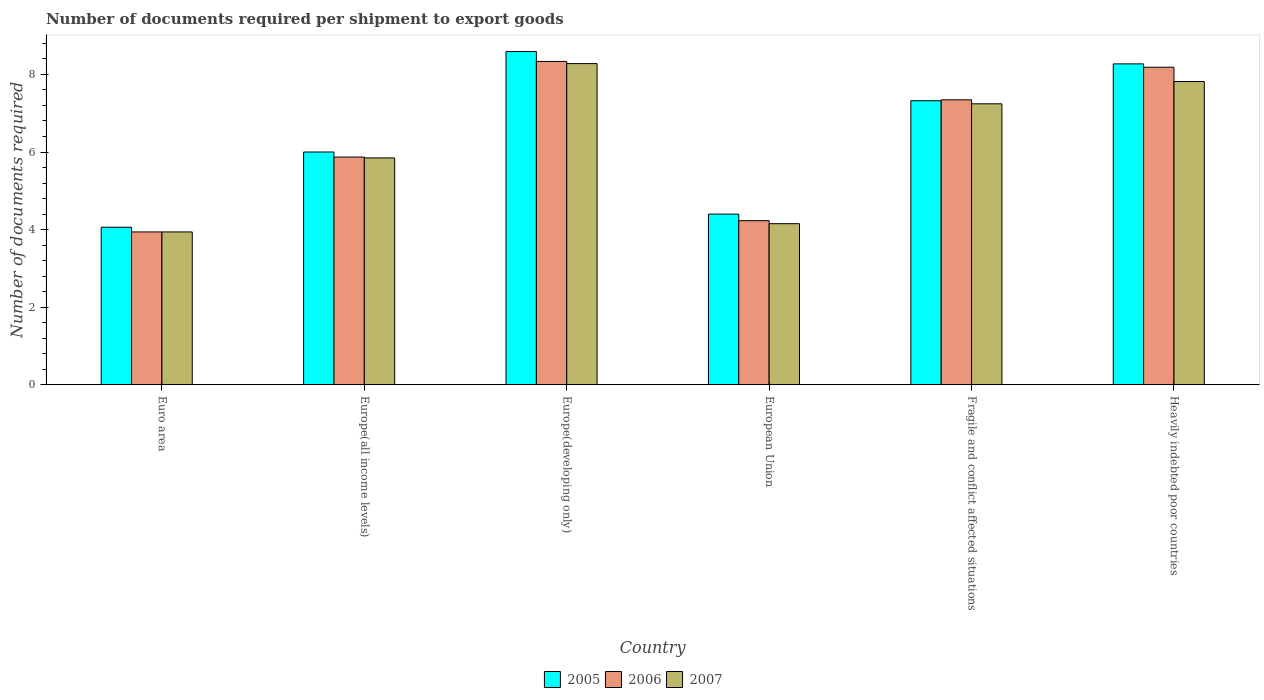How many bars are there on the 6th tick from the left?
Make the answer very short. 3. What is the number of documents required per shipment to export goods in 2005 in Europe(developing only)?
Your answer should be compact. 8.59. Across all countries, what is the maximum number of documents required per shipment to export goods in 2007?
Offer a very short reply. 8.28. Across all countries, what is the minimum number of documents required per shipment to export goods in 2007?
Provide a short and direct response. 3.94. In which country was the number of documents required per shipment to export goods in 2006 maximum?
Provide a short and direct response. Europe(developing only). In which country was the number of documents required per shipment to export goods in 2006 minimum?
Offer a very short reply. Euro area. What is the total number of documents required per shipment to export goods in 2007 in the graph?
Provide a succinct answer. 37.28. What is the difference between the number of documents required per shipment to export goods in 2006 in Fragile and conflict affected situations and that in Heavily indebted poor countries?
Ensure brevity in your answer.  -0.84. What is the difference between the number of documents required per shipment to export goods in 2006 in Europe(all income levels) and the number of documents required per shipment to export goods in 2007 in Heavily indebted poor countries?
Your response must be concise. -1.95. What is the average number of documents required per shipment to export goods in 2005 per country?
Your response must be concise. 6.44. What is the difference between the number of documents required per shipment to export goods of/in 2007 and number of documents required per shipment to export goods of/in 2005 in Fragile and conflict affected situations?
Offer a terse response. -0.08. What is the ratio of the number of documents required per shipment to export goods in 2005 in Europe(all income levels) to that in Fragile and conflict affected situations?
Offer a very short reply. 0.82. Is the number of documents required per shipment to export goods in 2007 in Europe(all income levels) less than that in European Union?
Your answer should be very brief. No. What is the difference between the highest and the second highest number of documents required per shipment to export goods in 2005?
Offer a very short reply. 0.32. What is the difference between the highest and the lowest number of documents required per shipment to export goods in 2006?
Keep it short and to the point. 4.39. In how many countries, is the number of documents required per shipment to export goods in 2007 greater than the average number of documents required per shipment to export goods in 2007 taken over all countries?
Provide a succinct answer. 3. What does the 3rd bar from the left in European Union represents?
Your answer should be very brief. 2007. Is it the case that in every country, the sum of the number of documents required per shipment to export goods in 2005 and number of documents required per shipment to export goods in 2007 is greater than the number of documents required per shipment to export goods in 2006?
Provide a short and direct response. Yes. How many countries are there in the graph?
Offer a terse response. 6. What is the difference between two consecutive major ticks on the Y-axis?
Provide a succinct answer. 2. Where does the legend appear in the graph?
Offer a terse response. Bottom center. What is the title of the graph?
Offer a very short reply. Number of documents required per shipment to export goods. Does "1987" appear as one of the legend labels in the graph?
Give a very brief answer. No. What is the label or title of the X-axis?
Make the answer very short. Country. What is the label or title of the Y-axis?
Provide a succinct answer. Number of documents required. What is the Number of documents required in 2005 in Euro area?
Provide a short and direct response. 4.06. What is the Number of documents required in 2006 in Euro area?
Your answer should be very brief. 3.94. What is the Number of documents required in 2007 in Euro area?
Provide a short and direct response. 3.94. What is the Number of documents required in 2005 in Europe(all income levels)?
Your answer should be compact. 6. What is the Number of documents required in 2006 in Europe(all income levels)?
Offer a terse response. 5.87. What is the Number of documents required in 2007 in Europe(all income levels)?
Provide a succinct answer. 5.85. What is the Number of documents required in 2005 in Europe(developing only)?
Make the answer very short. 8.59. What is the Number of documents required of 2006 in Europe(developing only)?
Make the answer very short. 8.33. What is the Number of documents required of 2007 in Europe(developing only)?
Provide a succinct answer. 8.28. What is the Number of documents required of 2005 in European Union?
Keep it short and to the point. 4.4. What is the Number of documents required in 2006 in European Union?
Your answer should be very brief. 4.23. What is the Number of documents required of 2007 in European Union?
Provide a short and direct response. 4.15. What is the Number of documents required of 2005 in Fragile and conflict affected situations?
Your answer should be compact. 7.32. What is the Number of documents required of 2006 in Fragile and conflict affected situations?
Your answer should be compact. 7.34. What is the Number of documents required of 2007 in Fragile and conflict affected situations?
Your answer should be very brief. 7.24. What is the Number of documents required in 2005 in Heavily indebted poor countries?
Your response must be concise. 8.27. What is the Number of documents required of 2006 in Heavily indebted poor countries?
Keep it short and to the point. 8.18. What is the Number of documents required in 2007 in Heavily indebted poor countries?
Offer a terse response. 7.82. Across all countries, what is the maximum Number of documents required in 2005?
Make the answer very short. 8.59. Across all countries, what is the maximum Number of documents required in 2006?
Your answer should be compact. 8.33. Across all countries, what is the maximum Number of documents required of 2007?
Give a very brief answer. 8.28. Across all countries, what is the minimum Number of documents required in 2005?
Offer a very short reply. 4.06. Across all countries, what is the minimum Number of documents required of 2006?
Keep it short and to the point. 3.94. Across all countries, what is the minimum Number of documents required of 2007?
Offer a very short reply. 3.94. What is the total Number of documents required of 2005 in the graph?
Make the answer very short. 38.64. What is the total Number of documents required in 2006 in the graph?
Keep it short and to the point. 37.9. What is the total Number of documents required of 2007 in the graph?
Provide a short and direct response. 37.28. What is the difference between the Number of documents required of 2005 in Euro area and that in Europe(all income levels)?
Make the answer very short. -1.94. What is the difference between the Number of documents required in 2006 in Euro area and that in Europe(all income levels)?
Make the answer very short. -1.93. What is the difference between the Number of documents required of 2007 in Euro area and that in Europe(all income levels)?
Give a very brief answer. -1.91. What is the difference between the Number of documents required in 2005 in Euro area and that in Europe(developing only)?
Provide a succinct answer. -4.53. What is the difference between the Number of documents required in 2006 in Euro area and that in Europe(developing only)?
Keep it short and to the point. -4.39. What is the difference between the Number of documents required of 2007 in Euro area and that in Europe(developing only)?
Keep it short and to the point. -4.34. What is the difference between the Number of documents required of 2005 in Euro area and that in European Union?
Offer a very short reply. -0.34. What is the difference between the Number of documents required in 2006 in Euro area and that in European Union?
Keep it short and to the point. -0.29. What is the difference between the Number of documents required of 2007 in Euro area and that in European Union?
Ensure brevity in your answer.  -0.21. What is the difference between the Number of documents required of 2005 in Euro area and that in Fragile and conflict affected situations?
Ensure brevity in your answer.  -3.26. What is the difference between the Number of documents required of 2006 in Euro area and that in Fragile and conflict affected situations?
Offer a very short reply. -3.4. What is the difference between the Number of documents required of 2007 in Euro area and that in Fragile and conflict affected situations?
Your answer should be very brief. -3.3. What is the difference between the Number of documents required in 2005 in Euro area and that in Heavily indebted poor countries?
Your answer should be compact. -4.21. What is the difference between the Number of documents required of 2006 in Euro area and that in Heavily indebted poor countries?
Your response must be concise. -4.24. What is the difference between the Number of documents required of 2007 in Euro area and that in Heavily indebted poor countries?
Keep it short and to the point. -3.87. What is the difference between the Number of documents required in 2005 in Europe(all income levels) and that in Europe(developing only)?
Provide a short and direct response. -2.59. What is the difference between the Number of documents required in 2006 in Europe(all income levels) and that in Europe(developing only)?
Make the answer very short. -2.46. What is the difference between the Number of documents required of 2007 in Europe(all income levels) and that in Europe(developing only)?
Provide a succinct answer. -2.43. What is the difference between the Number of documents required of 2005 in Europe(all income levels) and that in European Union?
Provide a short and direct response. 1.6. What is the difference between the Number of documents required in 2006 in Europe(all income levels) and that in European Union?
Ensure brevity in your answer.  1.64. What is the difference between the Number of documents required in 2007 in Europe(all income levels) and that in European Union?
Make the answer very short. 1.69. What is the difference between the Number of documents required in 2005 in Europe(all income levels) and that in Fragile and conflict affected situations?
Provide a succinct answer. -1.32. What is the difference between the Number of documents required of 2006 in Europe(all income levels) and that in Fragile and conflict affected situations?
Provide a short and direct response. -1.48. What is the difference between the Number of documents required in 2007 in Europe(all income levels) and that in Fragile and conflict affected situations?
Keep it short and to the point. -1.39. What is the difference between the Number of documents required of 2005 in Europe(all income levels) and that in Heavily indebted poor countries?
Make the answer very short. -2.27. What is the difference between the Number of documents required of 2006 in Europe(all income levels) and that in Heavily indebted poor countries?
Provide a short and direct response. -2.31. What is the difference between the Number of documents required of 2007 in Europe(all income levels) and that in Heavily indebted poor countries?
Ensure brevity in your answer.  -1.97. What is the difference between the Number of documents required of 2005 in Europe(developing only) and that in European Union?
Your answer should be compact. 4.19. What is the difference between the Number of documents required in 2006 in Europe(developing only) and that in European Union?
Ensure brevity in your answer.  4.1. What is the difference between the Number of documents required in 2007 in Europe(developing only) and that in European Union?
Make the answer very short. 4.12. What is the difference between the Number of documents required of 2005 in Europe(developing only) and that in Fragile and conflict affected situations?
Offer a terse response. 1.27. What is the difference between the Number of documents required in 2007 in Europe(developing only) and that in Fragile and conflict affected situations?
Make the answer very short. 1.04. What is the difference between the Number of documents required of 2005 in Europe(developing only) and that in Heavily indebted poor countries?
Ensure brevity in your answer.  0.32. What is the difference between the Number of documents required in 2006 in Europe(developing only) and that in Heavily indebted poor countries?
Provide a short and direct response. 0.15. What is the difference between the Number of documents required in 2007 in Europe(developing only) and that in Heavily indebted poor countries?
Provide a succinct answer. 0.46. What is the difference between the Number of documents required in 2005 in European Union and that in Fragile and conflict affected situations?
Make the answer very short. -2.92. What is the difference between the Number of documents required in 2006 in European Union and that in Fragile and conflict affected situations?
Offer a terse response. -3.11. What is the difference between the Number of documents required of 2007 in European Union and that in Fragile and conflict affected situations?
Your response must be concise. -3.09. What is the difference between the Number of documents required in 2005 in European Union and that in Heavily indebted poor countries?
Make the answer very short. -3.87. What is the difference between the Number of documents required in 2006 in European Union and that in Heavily indebted poor countries?
Your answer should be very brief. -3.95. What is the difference between the Number of documents required in 2007 in European Union and that in Heavily indebted poor countries?
Your answer should be compact. -3.66. What is the difference between the Number of documents required in 2005 in Fragile and conflict affected situations and that in Heavily indebted poor countries?
Your response must be concise. -0.95. What is the difference between the Number of documents required of 2006 in Fragile and conflict affected situations and that in Heavily indebted poor countries?
Offer a terse response. -0.84. What is the difference between the Number of documents required of 2007 in Fragile and conflict affected situations and that in Heavily indebted poor countries?
Keep it short and to the point. -0.57. What is the difference between the Number of documents required in 2005 in Euro area and the Number of documents required in 2006 in Europe(all income levels)?
Give a very brief answer. -1.81. What is the difference between the Number of documents required in 2005 in Euro area and the Number of documents required in 2007 in Europe(all income levels)?
Give a very brief answer. -1.79. What is the difference between the Number of documents required of 2006 in Euro area and the Number of documents required of 2007 in Europe(all income levels)?
Give a very brief answer. -1.91. What is the difference between the Number of documents required of 2005 in Euro area and the Number of documents required of 2006 in Europe(developing only)?
Keep it short and to the point. -4.27. What is the difference between the Number of documents required of 2005 in Euro area and the Number of documents required of 2007 in Europe(developing only)?
Provide a succinct answer. -4.22. What is the difference between the Number of documents required of 2006 in Euro area and the Number of documents required of 2007 in Europe(developing only)?
Provide a short and direct response. -4.34. What is the difference between the Number of documents required in 2005 in Euro area and the Number of documents required in 2006 in European Union?
Your response must be concise. -0.17. What is the difference between the Number of documents required in 2005 in Euro area and the Number of documents required in 2007 in European Union?
Give a very brief answer. -0.09. What is the difference between the Number of documents required in 2006 in Euro area and the Number of documents required in 2007 in European Union?
Offer a terse response. -0.21. What is the difference between the Number of documents required in 2005 in Euro area and the Number of documents required in 2006 in Fragile and conflict affected situations?
Give a very brief answer. -3.28. What is the difference between the Number of documents required of 2005 in Euro area and the Number of documents required of 2007 in Fragile and conflict affected situations?
Give a very brief answer. -3.18. What is the difference between the Number of documents required in 2006 in Euro area and the Number of documents required in 2007 in Fragile and conflict affected situations?
Offer a terse response. -3.3. What is the difference between the Number of documents required in 2005 in Euro area and the Number of documents required in 2006 in Heavily indebted poor countries?
Provide a succinct answer. -4.12. What is the difference between the Number of documents required of 2005 in Euro area and the Number of documents required of 2007 in Heavily indebted poor countries?
Ensure brevity in your answer.  -3.75. What is the difference between the Number of documents required in 2006 in Euro area and the Number of documents required in 2007 in Heavily indebted poor countries?
Keep it short and to the point. -3.87. What is the difference between the Number of documents required in 2005 in Europe(all income levels) and the Number of documents required in 2006 in Europe(developing only)?
Provide a short and direct response. -2.33. What is the difference between the Number of documents required in 2005 in Europe(all income levels) and the Number of documents required in 2007 in Europe(developing only)?
Offer a terse response. -2.28. What is the difference between the Number of documents required of 2006 in Europe(all income levels) and the Number of documents required of 2007 in Europe(developing only)?
Offer a very short reply. -2.41. What is the difference between the Number of documents required of 2005 in Europe(all income levels) and the Number of documents required of 2006 in European Union?
Offer a terse response. 1.77. What is the difference between the Number of documents required in 2005 in Europe(all income levels) and the Number of documents required in 2007 in European Union?
Offer a terse response. 1.85. What is the difference between the Number of documents required in 2006 in Europe(all income levels) and the Number of documents required in 2007 in European Union?
Your answer should be very brief. 1.72. What is the difference between the Number of documents required in 2005 in Europe(all income levels) and the Number of documents required in 2006 in Fragile and conflict affected situations?
Your answer should be compact. -1.34. What is the difference between the Number of documents required of 2005 in Europe(all income levels) and the Number of documents required of 2007 in Fragile and conflict affected situations?
Give a very brief answer. -1.24. What is the difference between the Number of documents required in 2006 in Europe(all income levels) and the Number of documents required in 2007 in Fragile and conflict affected situations?
Keep it short and to the point. -1.37. What is the difference between the Number of documents required in 2005 in Europe(all income levels) and the Number of documents required in 2006 in Heavily indebted poor countries?
Provide a short and direct response. -2.18. What is the difference between the Number of documents required of 2005 in Europe(all income levels) and the Number of documents required of 2007 in Heavily indebted poor countries?
Your answer should be very brief. -1.82. What is the difference between the Number of documents required of 2006 in Europe(all income levels) and the Number of documents required of 2007 in Heavily indebted poor countries?
Your answer should be compact. -1.95. What is the difference between the Number of documents required in 2005 in Europe(developing only) and the Number of documents required in 2006 in European Union?
Provide a short and direct response. 4.36. What is the difference between the Number of documents required in 2005 in Europe(developing only) and the Number of documents required in 2007 in European Union?
Offer a terse response. 4.43. What is the difference between the Number of documents required in 2006 in Europe(developing only) and the Number of documents required in 2007 in European Union?
Provide a succinct answer. 4.18. What is the difference between the Number of documents required of 2005 in Europe(developing only) and the Number of documents required of 2006 in Fragile and conflict affected situations?
Ensure brevity in your answer.  1.24. What is the difference between the Number of documents required in 2005 in Europe(developing only) and the Number of documents required in 2007 in Fragile and conflict affected situations?
Your answer should be compact. 1.35. What is the difference between the Number of documents required in 2006 in Europe(developing only) and the Number of documents required in 2007 in Fragile and conflict affected situations?
Provide a short and direct response. 1.09. What is the difference between the Number of documents required of 2005 in Europe(developing only) and the Number of documents required of 2006 in Heavily indebted poor countries?
Offer a very short reply. 0.4. What is the difference between the Number of documents required of 2005 in Europe(developing only) and the Number of documents required of 2007 in Heavily indebted poor countries?
Make the answer very short. 0.77. What is the difference between the Number of documents required in 2006 in Europe(developing only) and the Number of documents required in 2007 in Heavily indebted poor countries?
Your answer should be very brief. 0.52. What is the difference between the Number of documents required of 2005 in European Union and the Number of documents required of 2006 in Fragile and conflict affected situations?
Provide a succinct answer. -2.94. What is the difference between the Number of documents required in 2005 in European Union and the Number of documents required in 2007 in Fragile and conflict affected situations?
Ensure brevity in your answer.  -2.84. What is the difference between the Number of documents required of 2006 in European Union and the Number of documents required of 2007 in Fragile and conflict affected situations?
Your response must be concise. -3.01. What is the difference between the Number of documents required in 2005 in European Union and the Number of documents required in 2006 in Heavily indebted poor countries?
Offer a terse response. -3.78. What is the difference between the Number of documents required in 2005 in European Union and the Number of documents required in 2007 in Heavily indebted poor countries?
Make the answer very short. -3.42. What is the difference between the Number of documents required of 2006 in European Union and the Number of documents required of 2007 in Heavily indebted poor countries?
Ensure brevity in your answer.  -3.58. What is the difference between the Number of documents required of 2005 in Fragile and conflict affected situations and the Number of documents required of 2006 in Heavily indebted poor countries?
Ensure brevity in your answer.  -0.86. What is the difference between the Number of documents required in 2005 in Fragile and conflict affected situations and the Number of documents required in 2007 in Heavily indebted poor countries?
Give a very brief answer. -0.49. What is the difference between the Number of documents required of 2006 in Fragile and conflict affected situations and the Number of documents required of 2007 in Heavily indebted poor countries?
Make the answer very short. -0.47. What is the average Number of documents required of 2005 per country?
Offer a very short reply. 6.44. What is the average Number of documents required of 2006 per country?
Your answer should be very brief. 6.32. What is the average Number of documents required in 2007 per country?
Your response must be concise. 6.21. What is the difference between the Number of documents required of 2005 and Number of documents required of 2006 in Euro area?
Provide a succinct answer. 0.12. What is the difference between the Number of documents required in 2005 and Number of documents required in 2007 in Euro area?
Make the answer very short. 0.12. What is the difference between the Number of documents required in 2005 and Number of documents required in 2006 in Europe(all income levels)?
Offer a terse response. 0.13. What is the difference between the Number of documents required of 2005 and Number of documents required of 2007 in Europe(all income levels)?
Your response must be concise. 0.15. What is the difference between the Number of documents required in 2006 and Number of documents required in 2007 in Europe(all income levels)?
Keep it short and to the point. 0.02. What is the difference between the Number of documents required in 2005 and Number of documents required in 2006 in Europe(developing only)?
Offer a very short reply. 0.25. What is the difference between the Number of documents required of 2005 and Number of documents required of 2007 in Europe(developing only)?
Provide a succinct answer. 0.31. What is the difference between the Number of documents required in 2006 and Number of documents required in 2007 in Europe(developing only)?
Keep it short and to the point. 0.06. What is the difference between the Number of documents required of 2005 and Number of documents required of 2006 in European Union?
Provide a short and direct response. 0.17. What is the difference between the Number of documents required in 2005 and Number of documents required in 2007 in European Union?
Make the answer very short. 0.25. What is the difference between the Number of documents required of 2006 and Number of documents required of 2007 in European Union?
Give a very brief answer. 0.08. What is the difference between the Number of documents required in 2005 and Number of documents required in 2006 in Fragile and conflict affected situations?
Make the answer very short. -0.02. What is the difference between the Number of documents required in 2006 and Number of documents required in 2007 in Fragile and conflict affected situations?
Offer a very short reply. 0.1. What is the difference between the Number of documents required of 2005 and Number of documents required of 2006 in Heavily indebted poor countries?
Make the answer very short. 0.09. What is the difference between the Number of documents required of 2005 and Number of documents required of 2007 in Heavily indebted poor countries?
Make the answer very short. 0.45. What is the difference between the Number of documents required of 2006 and Number of documents required of 2007 in Heavily indebted poor countries?
Offer a very short reply. 0.37. What is the ratio of the Number of documents required in 2005 in Euro area to that in Europe(all income levels)?
Your answer should be compact. 0.68. What is the ratio of the Number of documents required in 2006 in Euro area to that in Europe(all income levels)?
Make the answer very short. 0.67. What is the ratio of the Number of documents required in 2007 in Euro area to that in Europe(all income levels)?
Give a very brief answer. 0.67. What is the ratio of the Number of documents required of 2005 in Euro area to that in Europe(developing only)?
Offer a terse response. 0.47. What is the ratio of the Number of documents required in 2006 in Euro area to that in Europe(developing only)?
Give a very brief answer. 0.47. What is the ratio of the Number of documents required in 2007 in Euro area to that in Europe(developing only)?
Your response must be concise. 0.48. What is the ratio of the Number of documents required of 2005 in Euro area to that in European Union?
Give a very brief answer. 0.92. What is the ratio of the Number of documents required of 2006 in Euro area to that in European Union?
Provide a succinct answer. 0.93. What is the ratio of the Number of documents required of 2007 in Euro area to that in European Union?
Give a very brief answer. 0.95. What is the ratio of the Number of documents required of 2005 in Euro area to that in Fragile and conflict affected situations?
Give a very brief answer. 0.55. What is the ratio of the Number of documents required in 2006 in Euro area to that in Fragile and conflict affected situations?
Your answer should be compact. 0.54. What is the ratio of the Number of documents required in 2007 in Euro area to that in Fragile and conflict affected situations?
Ensure brevity in your answer.  0.54. What is the ratio of the Number of documents required in 2005 in Euro area to that in Heavily indebted poor countries?
Your answer should be compact. 0.49. What is the ratio of the Number of documents required in 2006 in Euro area to that in Heavily indebted poor countries?
Provide a short and direct response. 0.48. What is the ratio of the Number of documents required in 2007 in Euro area to that in Heavily indebted poor countries?
Provide a succinct answer. 0.5. What is the ratio of the Number of documents required of 2005 in Europe(all income levels) to that in Europe(developing only)?
Make the answer very short. 0.7. What is the ratio of the Number of documents required in 2006 in Europe(all income levels) to that in Europe(developing only)?
Make the answer very short. 0.7. What is the ratio of the Number of documents required in 2007 in Europe(all income levels) to that in Europe(developing only)?
Keep it short and to the point. 0.71. What is the ratio of the Number of documents required of 2005 in Europe(all income levels) to that in European Union?
Your response must be concise. 1.36. What is the ratio of the Number of documents required in 2006 in Europe(all income levels) to that in European Union?
Provide a succinct answer. 1.39. What is the ratio of the Number of documents required of 2007 in Europe(all income levels) to that in European Union?
Offer a very short reply. 1.41. What is the ratio of the Number of documents required in 2005 in Europe(all income levels) to that in Fragile and conflict affected situations?
Offer a very short reply. 0.82. What is the ratio of the Number of documents required in 2006 in Europe(all income levels) to that in Fragile and conflict affected situations?
Provide a succinct answer. 0.8. What is the ratio of the Number of documents required in 2007 in Europe(all income levels) to that in Fragile and conflict affected situations?
Offer a very short reply. 0.81. What is the ratio of the Number of documents required of 2005 in Europe(all income levels) to that in Heavily indebted poor countries?
Offer a terse response. 0.73. What is the ratio of the Number of documents required in 2006 in Europe(all income levels) to that in Heavily indebted poor countries?
Your answer should be very brief. 0.72. What is the ratio of the Number of documents required in 2007 in Europe(all income levels) to that in Heavily indebted poor countries?
Your answer should be compact. 0.75. What is the ratio of the Number of documents required in 2005 in Europe(developing only) to that in European Union?
Give a very brief answer. 1.95. What is the ratio of the Number of documents required of 2006 in Europe(developing only) to that in European Union?
Provide a succinct answer. 1.97. What is the ratio of the Number of documents required in 2007 in Europe(developing only) to that in European Union?
Keep it short and to the point. 1.99. What is the ratio of the Number of documents required of 2005 in Europe(developing only) to that in Fragile and conflict affected situations?
Your response must be concise. 1.17. What is the ratio of the Number of documents required of 2006 in Europe(developing only) to that in Fragile and conflict affected situations?
Keep it short and to the point. 1.13. What is the ratio of the Number of documents required of 2007 in Europe(developing only) to that in Fragile and conflict affected situations?
Provide a short and direct response. 1.14. What is the ratio of the Number of documents required of 2005 in Europe(developing only) to that in Heavily indebted poor countries?
Keep it short and to the point. 1.04. What is the ratio of the Number of documents required in 2006 in Europe(developing only) to that in Heavily indebted poor countries?
Your response must be concise. 1.02. What is the ratio of the Number of documents required of 2007 in Europe(developing only) to that in Heavily indebted poor countries?
Provide a short and direct response. 1.06. What is the ratio of the Number of documents required in 2005 in European Union to that in Fragile and conflict affected situations?
Your answer should be compact. 0.6. What is the ratio of the Number of documents required in 2006 in European Union to that in Fragile and conflict affected situations?
Make the answer very short. 0.58. What is the ratio of the Number of documents required of 2007 in European Union to that in Fragile and conflict affected situations?
Provide a short and direct response. 0.57. What is the ratio of the Number of documents required in 2005 in European Union to that in Heavily indebted poor countries?
Ensure brevity in your answer.  0.53. What is the ratio of the Number of documents required in 2006 in European Union to that in Heavily indebted poor countries?
Make the answer very short. 0.52. What is the ratio of the Number of documents required in 2007 in European Union to that in Heavily indebted poor countries?
Offer a very short reply. 0.53. What is the ratio of the Number of documents required in 2005 in Fragile and conflict affected situations to that in Heavily indebted poor countries?
Offer a very short reply. 0.89. What is the ratio of the Number of documents required in 2006 in Fragile and conflict affected situations to that in Heavily indebted poor countries?
Offer a very short reply. 0.9. What is the ratio of the Number of documents required in 2007 in Fragile and conflict affected situations to that in Heavily indebted poor countries?
Your response must be concise. 0.93. What is the difference between the highest and the second highest Number of documents required in 2005?
Provide a short and direct response. 0.32. What is the difference between the highest and the second highest Number of documents required in 2006?
Offer a terse response. 0.15. What is the difference between the highest and the second highest Number of documents required in 2007?
Your response must be concise. 0.46. What is the difference between the highest and the lowest Number of documents required of 2005?
Offer a very short reply. 4.53. What is the difference between the highest and the lowest Number of documents required in 2006?
Give a very brief answer. 4.39. What is the difference between the highest and the lowest Number of documents required in 2007?
Your answer should be compact. 4.34. 